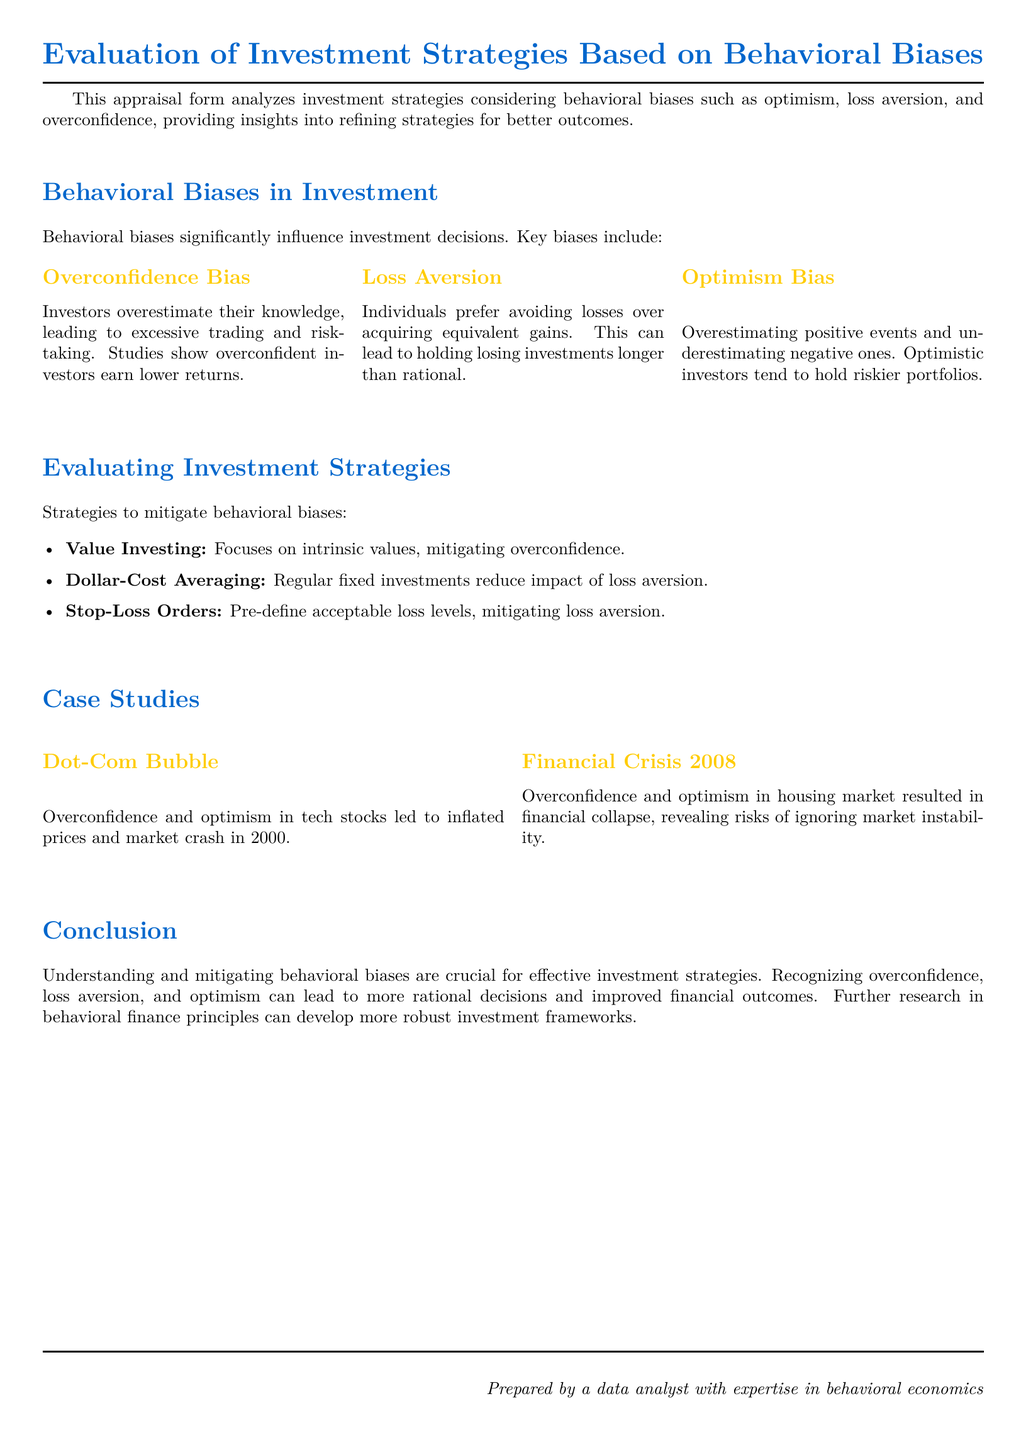What is the title of the document? The title of the document is stated at the top and is "Evaluation of Investment Strategies Based on Behavioral Biases."
Answer: Evaluation of Investment Strategies Based on Behavioral Biases What are the key biases discussed? The document lists "Overconfidence Bias," "Loss Aversion," and "Optimism Bias" as the key biases affecting investment decisions.
Answer: Overconfidence Bias, Loss Aversion, Optimism Bias What strategy focuses on intrinsic values? The document mentions "Value Investing" as a strategy that focuses on intrinsic values.
Answer: Value Investing Which case study illustrates optimism and overconfidence? The case study titled "Dot-Com Bubble" illustrates how optimism and overconfidence can lead to inflated prices.
Answer: Dot-Com Bubble What year did the financial crisis occur according to the document? The document refers to the financial crisis as happening in 2008.
Answer: 2008 What strategy mitigates loss aversion? The strategy "Dollar-Cost Averaging" is identified as a method to reduce the impact of loss aversion.
Answer: Dollar-Cost Averaging How does the document suggest to mitigate loss aversion? It suggests using "Stop-Loss Orders" to pre-define acceptable loss levels.
Answer: Stop-Loss Orders Which bias leads to excessive trading? The "Overconfidence Bias" is highlighted as leading to excessive trading and risk-taking.
Answer: Overconfidence Bias What is emphasized as crucial for effective investment strategies? The document emphasizes understanding and mitigating behavioral biases as crucial for effective investment strategies.
Answer: Understanding and mitigating behavioral biases 